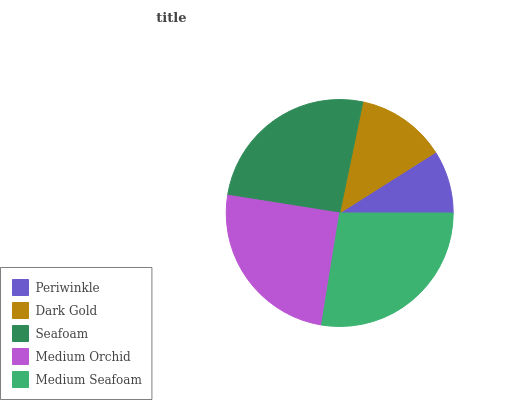Is Periwinkle the minimum?
Answer yes or no. Yes. Is Medium Seafoam the maximum?
Answer yes or no. Yes. Is Dark Gold the minimum?
Answer yes or no. No. Is Dark Gold the maximum?
Answer yes or no. No. Is Dark Gold greater than Periwinkle?
Answer yes or no. Yes. Is Periwinkle less than Dark Gold?
Answer yes or no. Yes. Is Periwinkle greater than Dark Gold?
Answer yes or no. No. Is Dark Gold less than Periwinkle?
Answer yes or no. No. Is Medium Orchid the high median?
Answer yes or no. Yes. Is Medium Orchid the low median?
Answer yes or no. Yes. Is Seafoam the high median?
Answer yes or no. No. Is Medium Seafoam the low median?
Answer yes or no. No. 